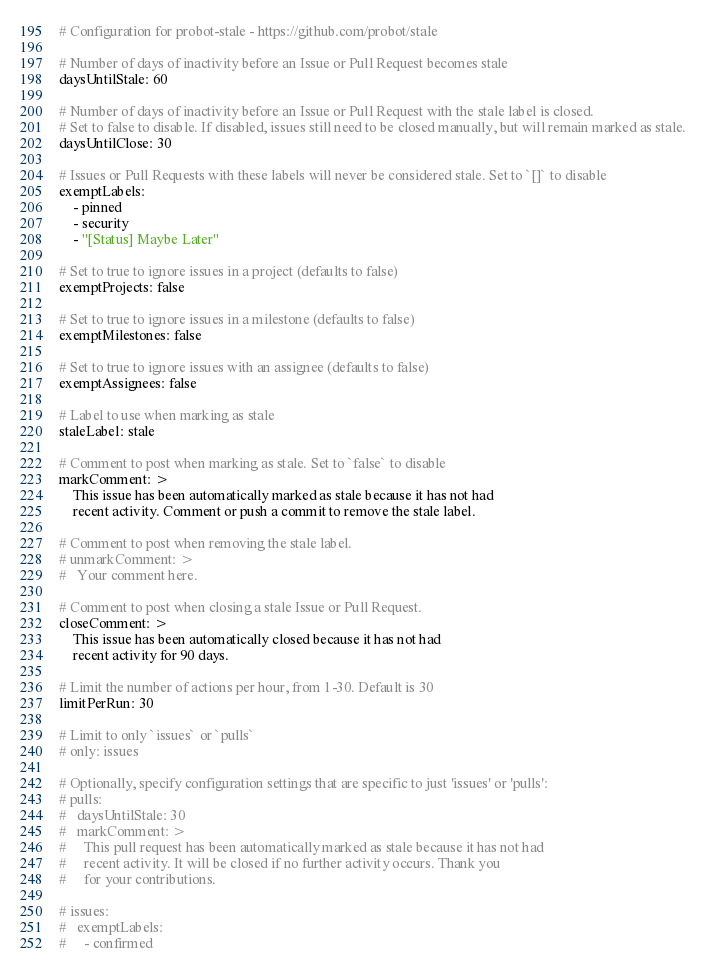Convert code to text. <code><loc_0><loc_0><loc_500><loc_500><_YAML_># Configuration for probot-stale - https://github.com/probot/stale

# Number of days of inactivity before an Issue or Pull Request becomes stale
daysUntilStale: 60

# Number of days of inactivity before an Issue or Pull Request with the stale label is closed.
# Set to false to disable. If disabled, issues still need to be closed manually, but will remain marked as stale.
daysUntilClose: 30

# Issues or Pull Requests with these labels will never be considered stale. Set to `[]` to disable
exemptLabels:
    - pinned
    - security
    - "[Status] Maybe Later"

# Set to true to ignore issues in a project (defaults to false)
exemptProjects: false

# Set to true to ignore issues in a milestone (defaults to false)
exemptMilestones: false

# Set to true to ignore issues with an assignee (defaults to false)
exemptAssignees: false

# Label to use when marking as stale
staleLabel: stale

# Comment to post when marking as stale. Set to `false` to disable
markComment: >
    This issue has been automatically marked as stale because it has not had
    recent activity. Comment or push a commit to remove the stale label.

# Comment to post when removing the stale label.
# unmarkComment: >
#   Your comment here.

# Comment to post when closing a stale Issue or Pull Request.
closeComment: >
    This issue has been automatically closed because it has not had
    recent activity for 90 days.

# Limit the number of actions per hour, from 1-30. Default is 30
limitPerRun: 30

# Limit to only `issues` or `pulls`
# only: issues

# Optionally, specify configuration settings that are specific to just 'issues' or 'pulls':
# pulls:
#   daysUntilStale: 30
#   markComment: >
#     This pull request has been automatically marked as stale because it has not had
#     recent activity. It will be closed if no further activity occurs. Thank you
#     for your contributions.

# issues:
#   exemptLabels:
#     - confirmed
</code> 